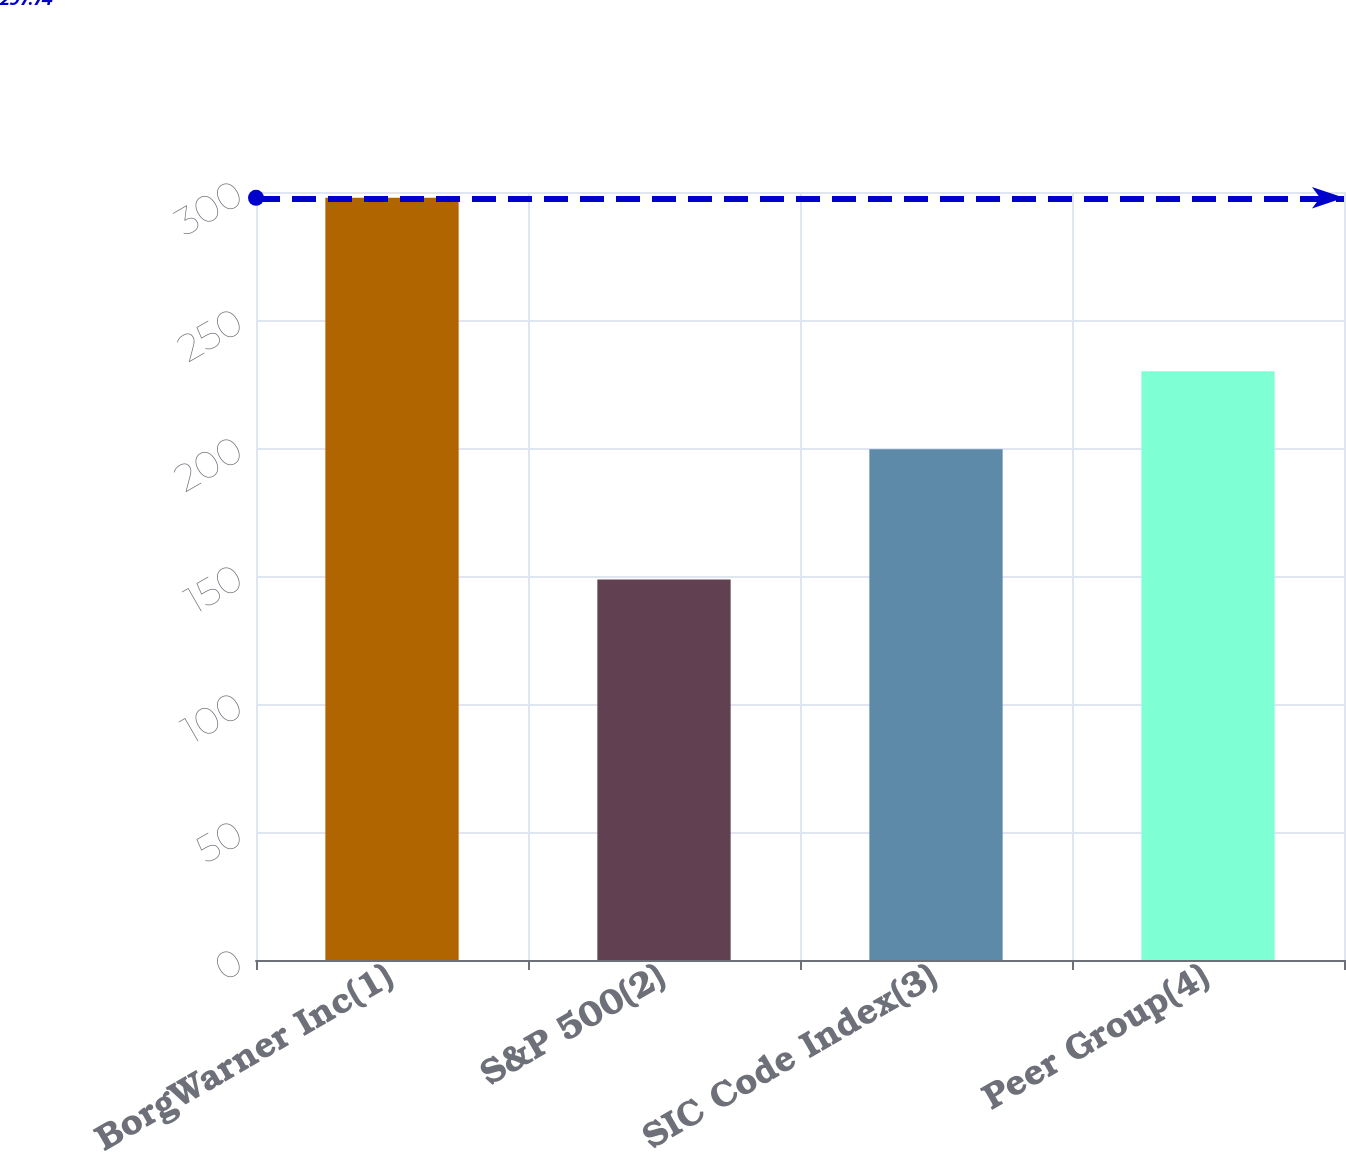Convert chart. <chart><loc_0><loc_0><loc_500><loc_500><bar_chart><fcel>BorgWarner Inc(1)<fcel>S&P 500(2)<fcel>SIC Code Index(3)<fcel>Peer Group(4)<nl><fcel>297.74<fcel>148.59<fcel>199.56<fcel>230.01<nl></chart> 